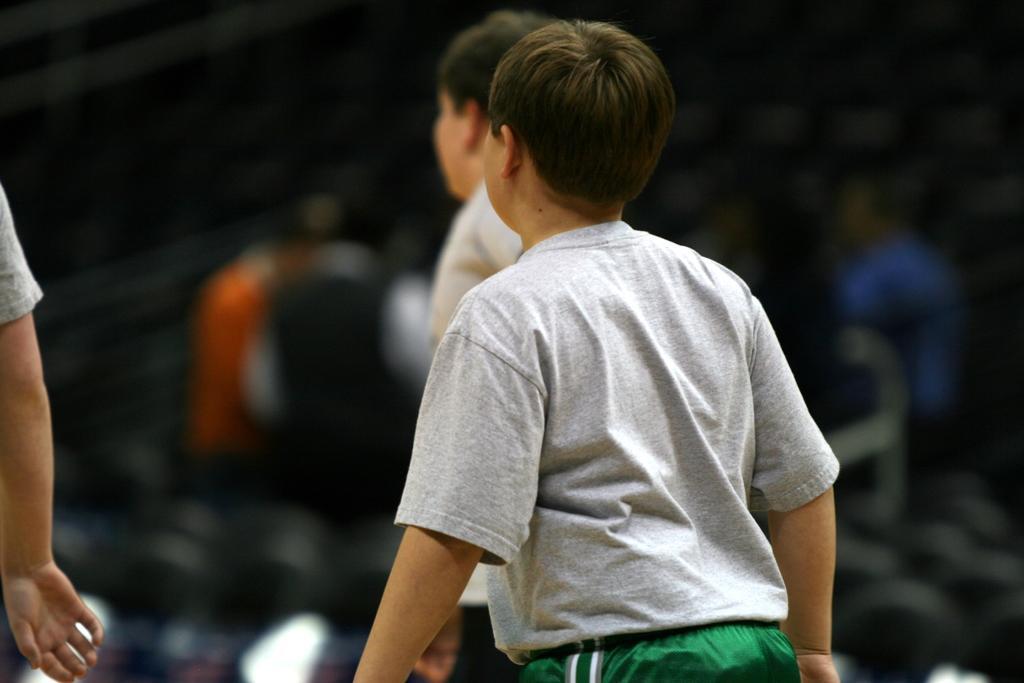Could you give a brief overview of what you see in this image? In this picture there are two boys wearing a grey color t-shirt and green shots, standing in the ground. Behind there is a blur background. 